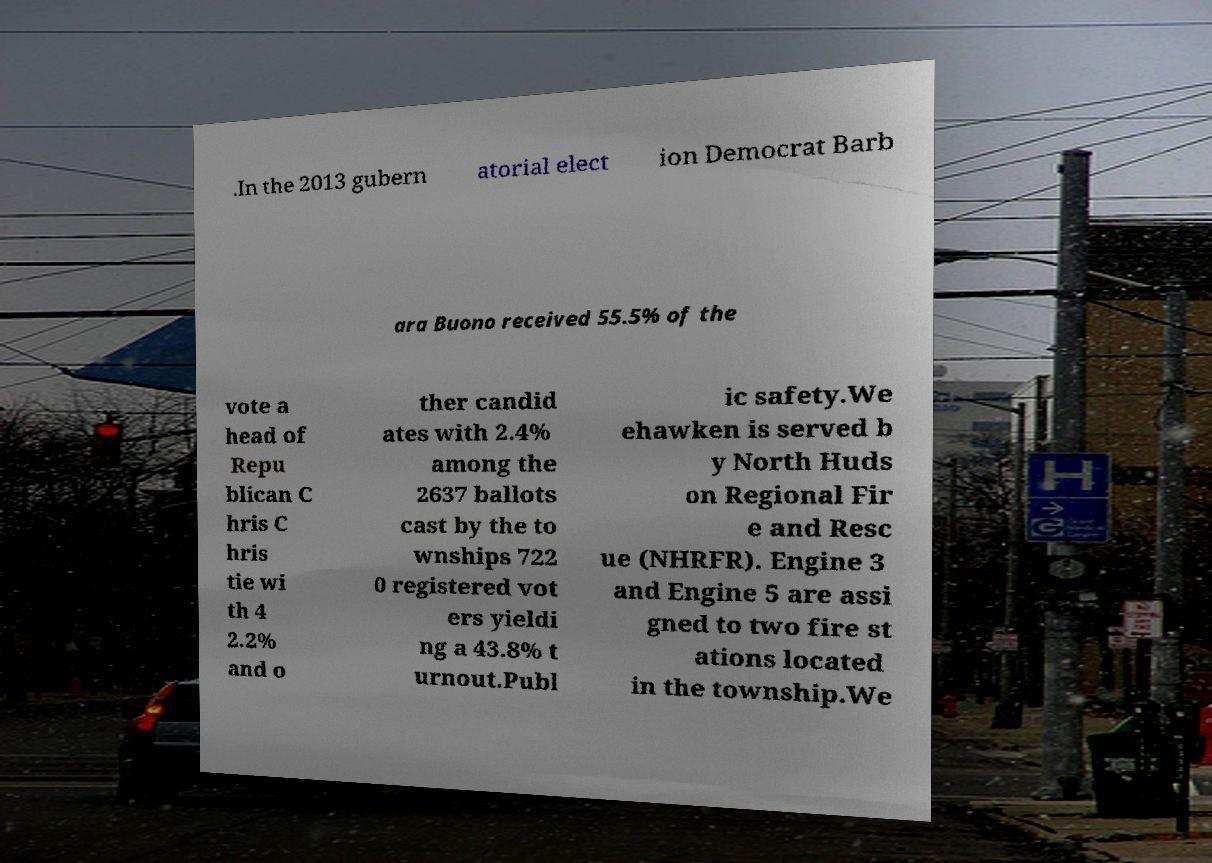Please identify and transcribe the text found in this image. .In the 2013 gubern atorial elect ion Democrat Barb ara Buono received 55.5% of the vote a head of Repu blican C hris C hris tie wi th 4 2.2% and o ther candid ates with 2.4% among the 2637 ballots cast by the to wnships 722 0 registered vot ers yieldi ng a 43.8% t urnout.Publ ic safety.We ehawken is served b y North Huds on Regional Fir e and Resc ue (NHRFR). Engine 3 and Engine 5 are assi gned to two fire st ations located in the township.We 